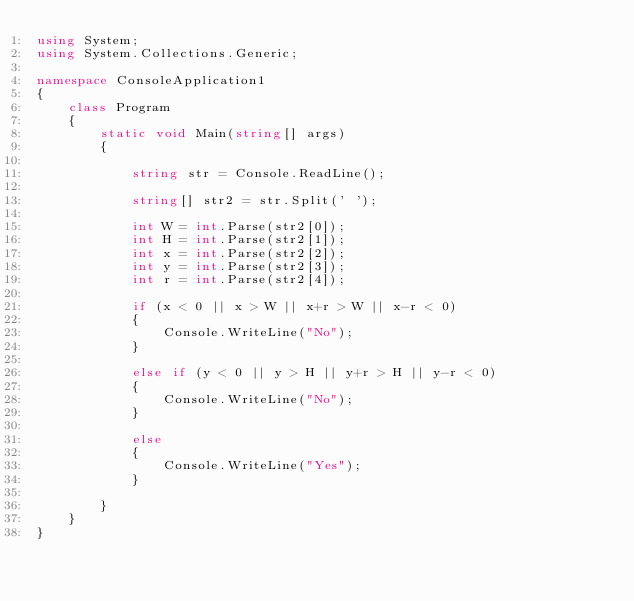<code> <loc_0><loc_0><loc_500><loc_500><_C#_>using System;
using System.Collections.Generic;

namespace ConsoleApplication1
{
    class Program
    {
        static void Main(string[] args)
        {

            string str = Console.ReadLine();

            string[] str2 = str.Split(' ');

            int W = int.Parse(str2[0]);
            int H = int.Parse(str2[1]);
            int x = int.Parse(str2[2]);
            int y = int.Parse(str2[3]);
            int r = int.Parse(str2[4]);

            if (x < 0 || x > W || x+r > W || x-r < 0)
            {
                Console.WriteLine("No");
            }

            else if (y < 0 || y > H || y+r > H || y-r < 0)
            {
                Console.WriteLine("No");
            }

            else
            {
                Console.WriteLine("Yes");
            }

        }
    }
}

</code> 